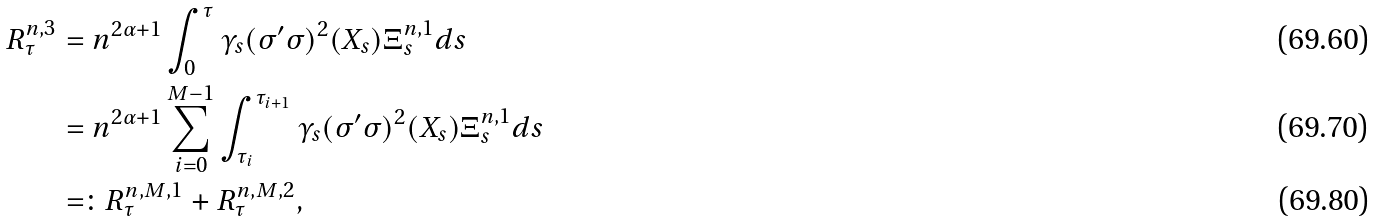Convert formula to latex. <formula><loc_0><loc_0><loc_500><loc_500>R ^ { n , 3 } _ { \tau } & = n ^ { 2 \alpha + 1 } \int ^ { \tau } _ { 0 } \gamma _ { s } ( \sigma ^ { \prime } \sigma ) ^ { 2 } ( X _ { s } ) \Xi ^ { n , 1 } _ { s } d s \\ & = n ^ { 2 \alpha + 1 } \sum _ { i = 0 } ^ { M - 1 } \int _ { \tau _ { i } } ^ { \tau _ { i + 1 } } \gamma _ { s } ( \sigma ^ { \prime } \sigma ) ^ { 2 } ( X _ { s } ) \Xi ^ { n , 1 } _ { s } d s \\ & = \colon R ^ { n , M , 1 } _ { \tau } + R ^ { n , M , 2 } _ { \tau } ,</formula> 